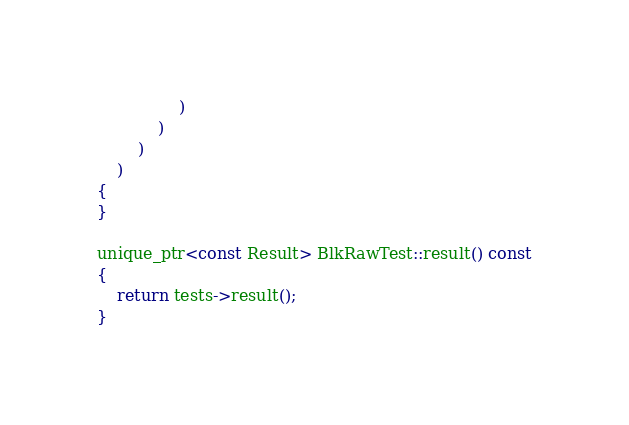Convert code to text. <code><loc_0><loc_0><loc_500><loc_500><_C++_>				)
			)
		)
	)
{
}

unique_ptr<const Result> BlkRawTest::result() const
{
	return tests->result();
}
</code> 